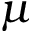<formula> <loc_0><loc_0><loc_500><loc_500>\mu</formula> 